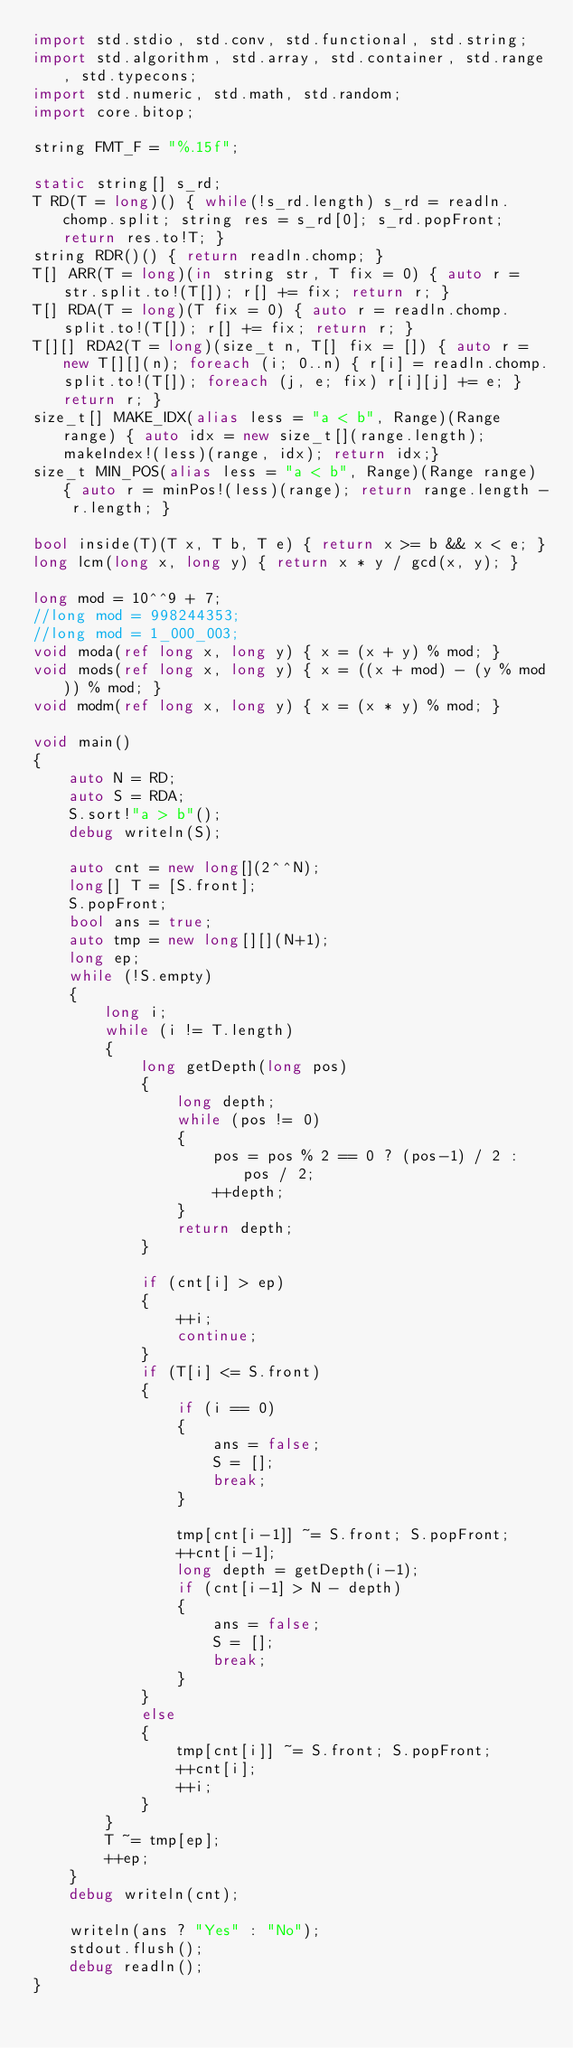Convert code to text. <code><loc_0><loc_0><loc_500><loc_500><_D_>import std.stdio, std.conv, std.functional, std.string;
import std.algorithm, std.array, std.container, std.range, std.typecons;
import std.numeric, std.math, std.random;
import core.bitop;

string FMT_F = "%.15f";

static string[] s_rd;
T RD(T = long)() { while(!s_rd.length) s_rd = readln.chomp.split; string res = s_rd[0]; s_rd.popFront; return res.to!T; }
string RDR()() { return readln.chomp; }
T[] ARR(T = long)(in string str, T fix = 0) { auto r = str.split.to!(T[]); r[] += fix; return r; }
T[] RDA(T = long)(T fix = 0) { auto r = readln.chomp.split.to!(T[]); r[] += fix; return r; }
T[][] RDA2(T = long)(size_t n, T[] fix = []) { auto r = new T[][](n); foreach (i; 0..n) { r[i] = readln.chomp.split.to!(T[]); foreach (j, e; fix) r[i][j] += e; } return r; }
size_t[] MAKE_IDX(alias less = "a < b", Range)(Range range) { auto idx = new size_t[](range.length); makeIndex!(less)(range, idx); return idx;}
size_t MIN_POS(alias less = "a < b", Range)(Range range) { auto r = minPos!(less)(range); return range.length - r.length; }

bool inside(T)(T x, T b, T e) { return x >= b && x < e; }
long lcm(long x, long y) { return x * y / gcd(x, y); }

long mod = 10^^9 + 7;
//long mod = 998244353;
//long mod = 1_000_003;
void moda(ref long x, long y) { x = (x + y) % mod; }
void mods(ref long x, long y) { x = ((x + mod) - (y % mod)) % mod; }
void modm(ref long x, long y) { x = (x * y) % mod; }

void main()
{
	auto N = RD;
	auto S = RDA;
	S.sort!"a > b"();
	debug writeln(S);

	auto cnt = new long[](2^^N);
	long[] T = [S.front];
	S.popFront;
	bool ans = true;
	auto tmp = new long[][](N+1);
	long ep;
	while (!S.empty)
	{
		long i;
		while (i != T.length)
		{
			long getDepth(long pos)
			{
				long depth;
				while (pos != 0)
				{
					pos = pos % 2 == 0 ? (pos-1) / 2 : pos / 2;
					++depth;
				}
				return depth;
			}

			if (cnt[i] > ep) 
			{
				++i;
				continue;
			}
			if (T[i] <= S.front)
			{
				if (i == 0)
				{
					ans = false;
					S = [];
					break;
				}

				tmp[cnt[i-1]] ~= S.front; S.popFront;
				++cnt[i-1];
				long depth = getDepth(i-1);
				if (cnt[i-1] > N - depth)
				{
					ans = false;
					S = [];
					break;
				}
			}
			else
			{
				tmp[cnt[i]] ~= S.front; S.popFront;
				++cnt[i];
				++i;
			}
		}
		T ~= tmp[ep];
		++ep;
	}
	debug writeln(cnt);

	writeln(ans ? "Yes" : "No");
	stdout.flush();
	debug readln();
}</code> 